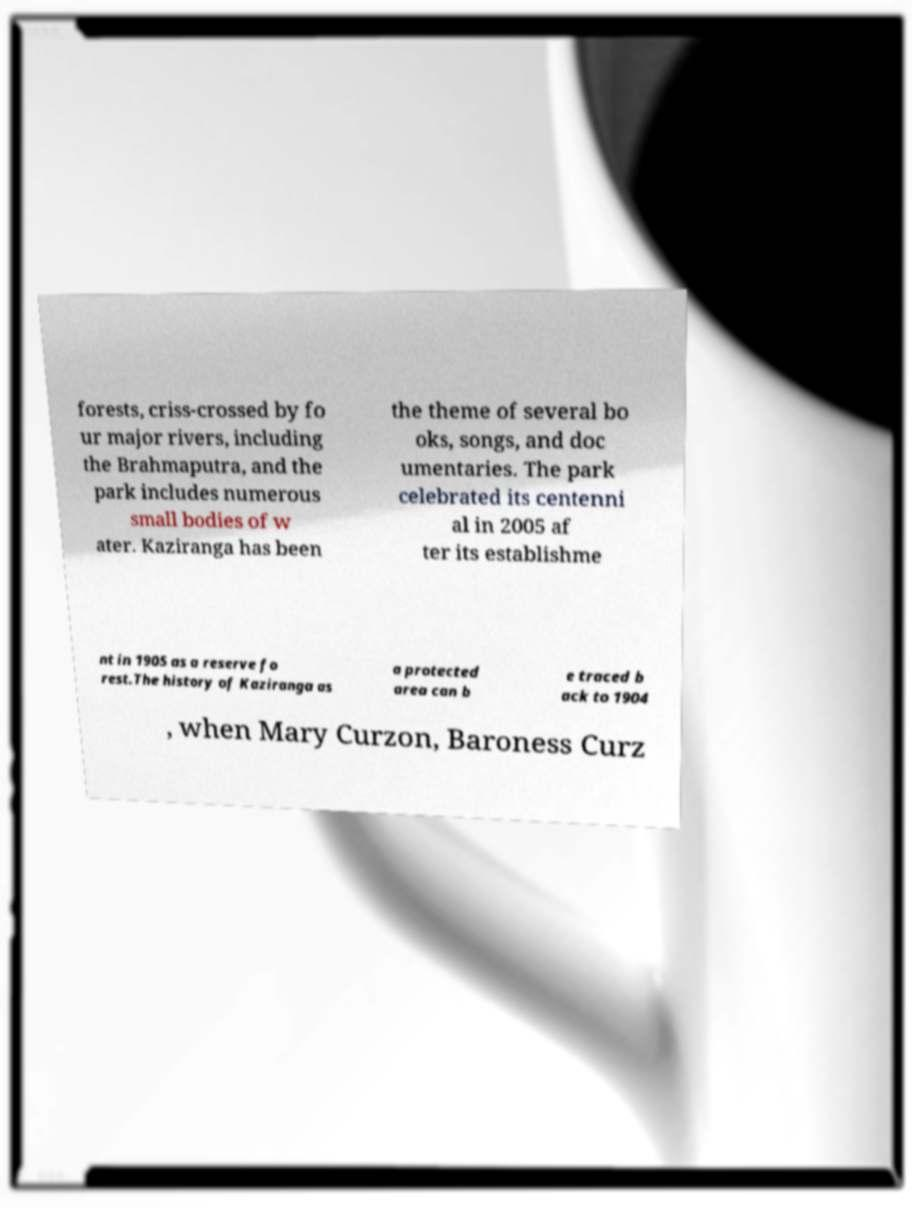There's text embedded in this image that I need extracted. Can you transcribe it verbatim? forests, criss-crossed by fo ur major rivers, including the Brahmaputra, and the park includes numerous small bodies of w ater. Kaziranga has been the theme of several bo oks, songs, and doc umentaries. The park celebrated its centenni al in 2005 af ter its establishme nt in 1905 as a reserve fo rest.The history of Kaziranga as a protected area can b e traced b ack to 1904 , when Mary Curzon, Baroness Curz 